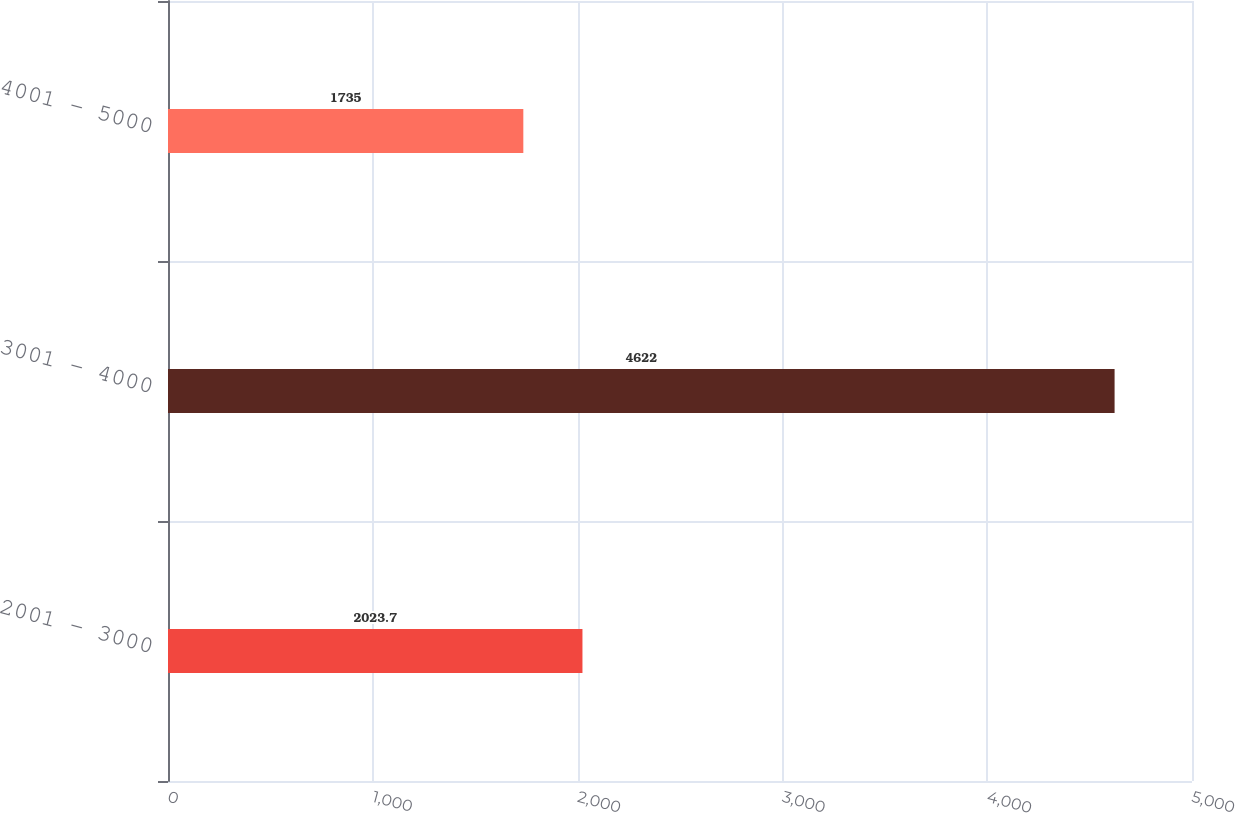Convert chart. <chart><loc_0><loc_0><loc_500><loc_500><bar_chart><fcel>2001 - 3000<fcel>3001 - 4000<fcel>4001 - 5000<nl><fcel>2023.7<fcel>4622<fcel>1735<nl></chart> 